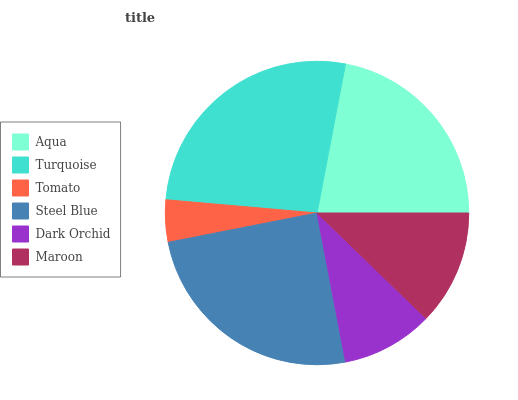Is Tomato the minimum?
Answer yes or no. Yes. Is Turquoise the maximum?
Answer yes or no. Yes. Is Turquoise the minimum?
Answer yes or no. No. Is Tomato the maximum?
Answer yes or no. No. Is Turquoise greater than Tomato?
Answer yes or no. Yes. Is Tomato less than Turquoise?
Answer yes or no. Yes. Is Tomato greater than Turquoise?
Answer yes or no. No. Is Turquoise less than Tomato?
Answer yes or no. No. Is Aqua the high median?
Answer yes or no. Yes. Is Maroon the low median?
Answer yes or no. Yes. Is Dark Orchid the high median?
Answer yes or no. No. Is Dark Orchid the low median?
Answer yes or no. No. 